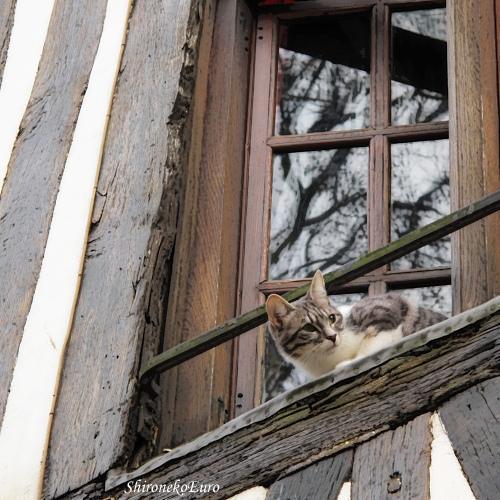How many eyes does this animal have?
Give a very brief answer. 2. 